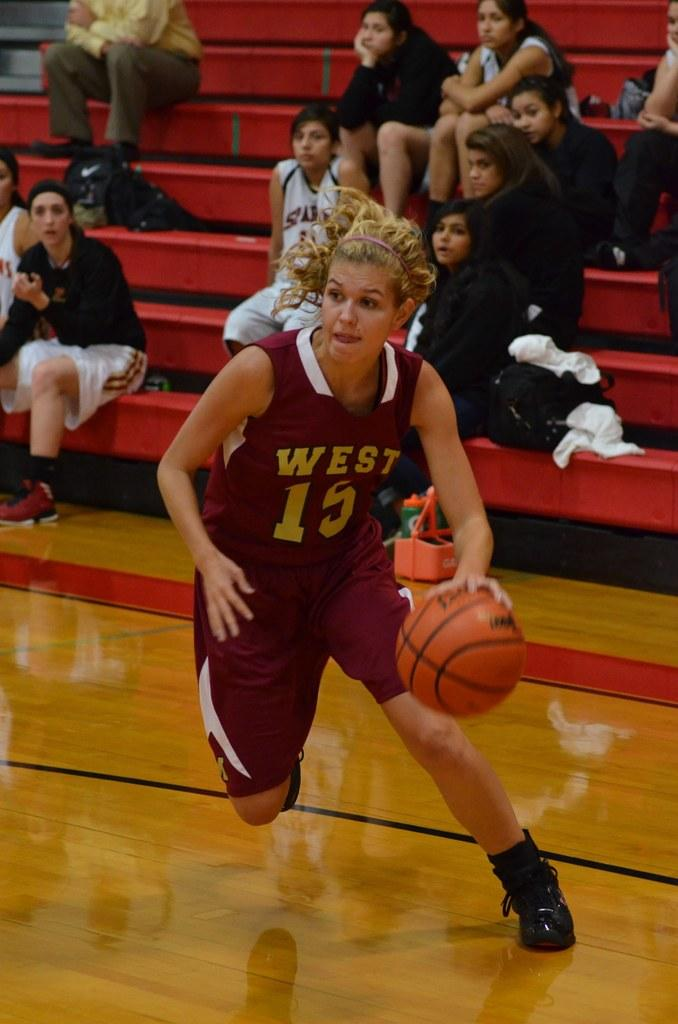Who is the main subject in the image? There is a woman in the image. What is the woman doing in the image? The woman is playing basketball. What can be seen in the background of the image? There are people sitting on benches in the background. What object is placed on the floor in the image? The fact does not specify the object placed on the floor, so we cannot answer this question definitively. Can you see a toad hopping in the image? No, there is no toad hopping in the image. 